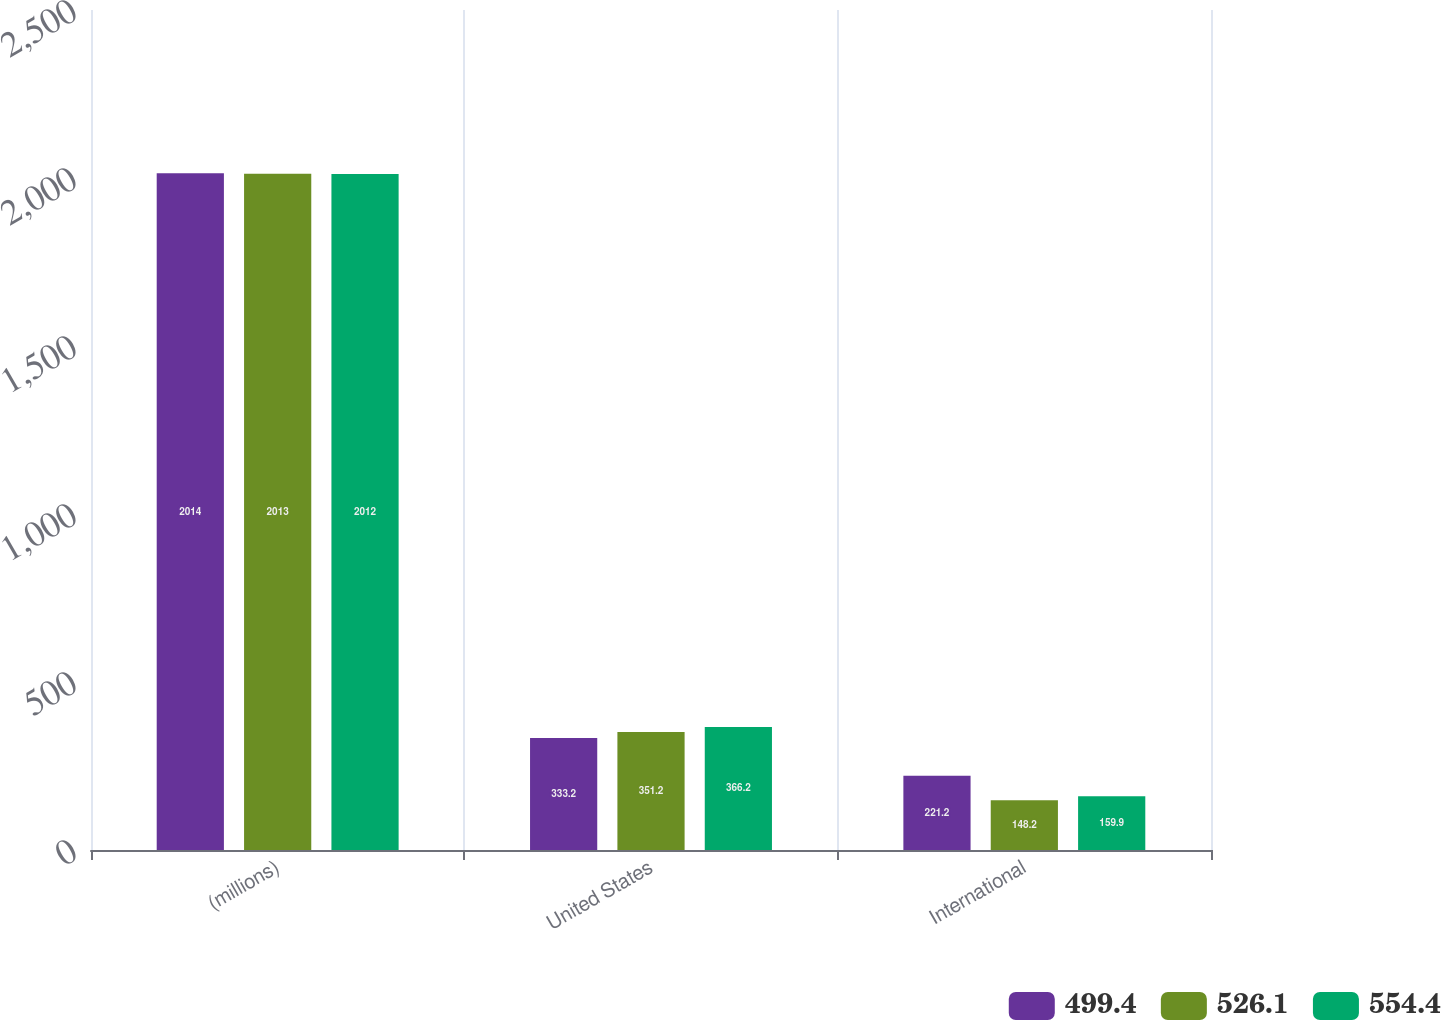<chart> <loc_0><loc_0><loc_500><loc_500><stacked_bar_chart><ecel><fcel>(millions)<fcel>United States<fcel>International<nl><fcel>499.4<fcel>2014<fcel>333.2<fcel>221.2<nl><fcel>526.1<fcel>2013<fcel>351.2<fcel>148.2<nl><fcel>554.4<fcel>2012<fcel>366.2<fcel>159.9<nl></chart> 